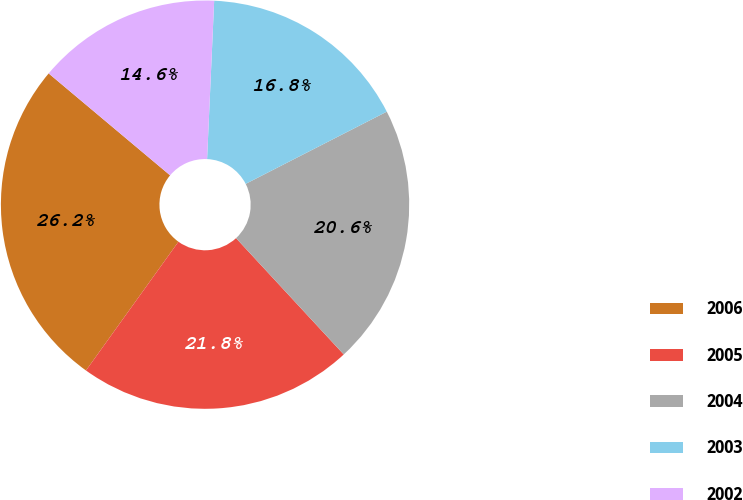Convert chart. <chart><loc_0><loc_0><loc_500><loc_500><pie_chart><fcel>2006<fcel>2005<fcel>2004<fcel>2003<fcel>2002<nl><fcel>26.2%<fcel>21.8%<fcel>20.64%<fcel>16.76%<fcel>14.6%<nl></chart> 